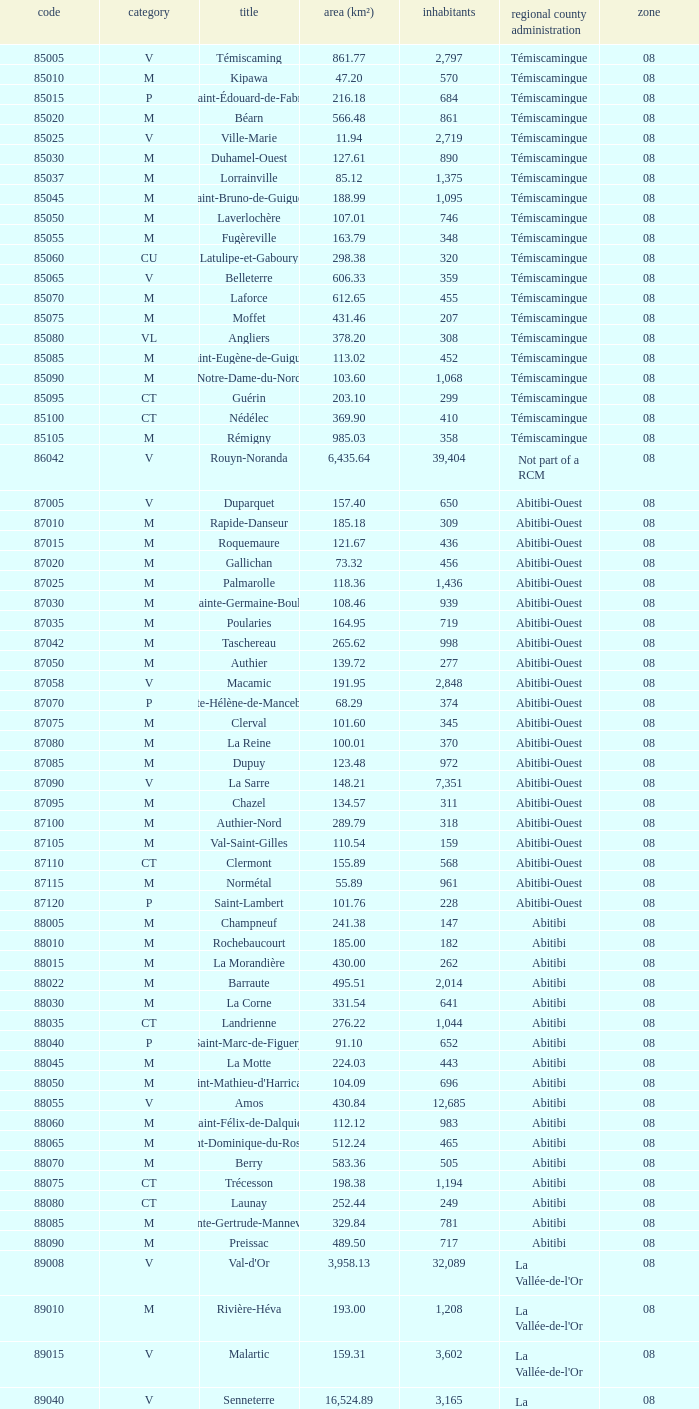What was the region for Malartic with 159.31 km2? 0.0. 